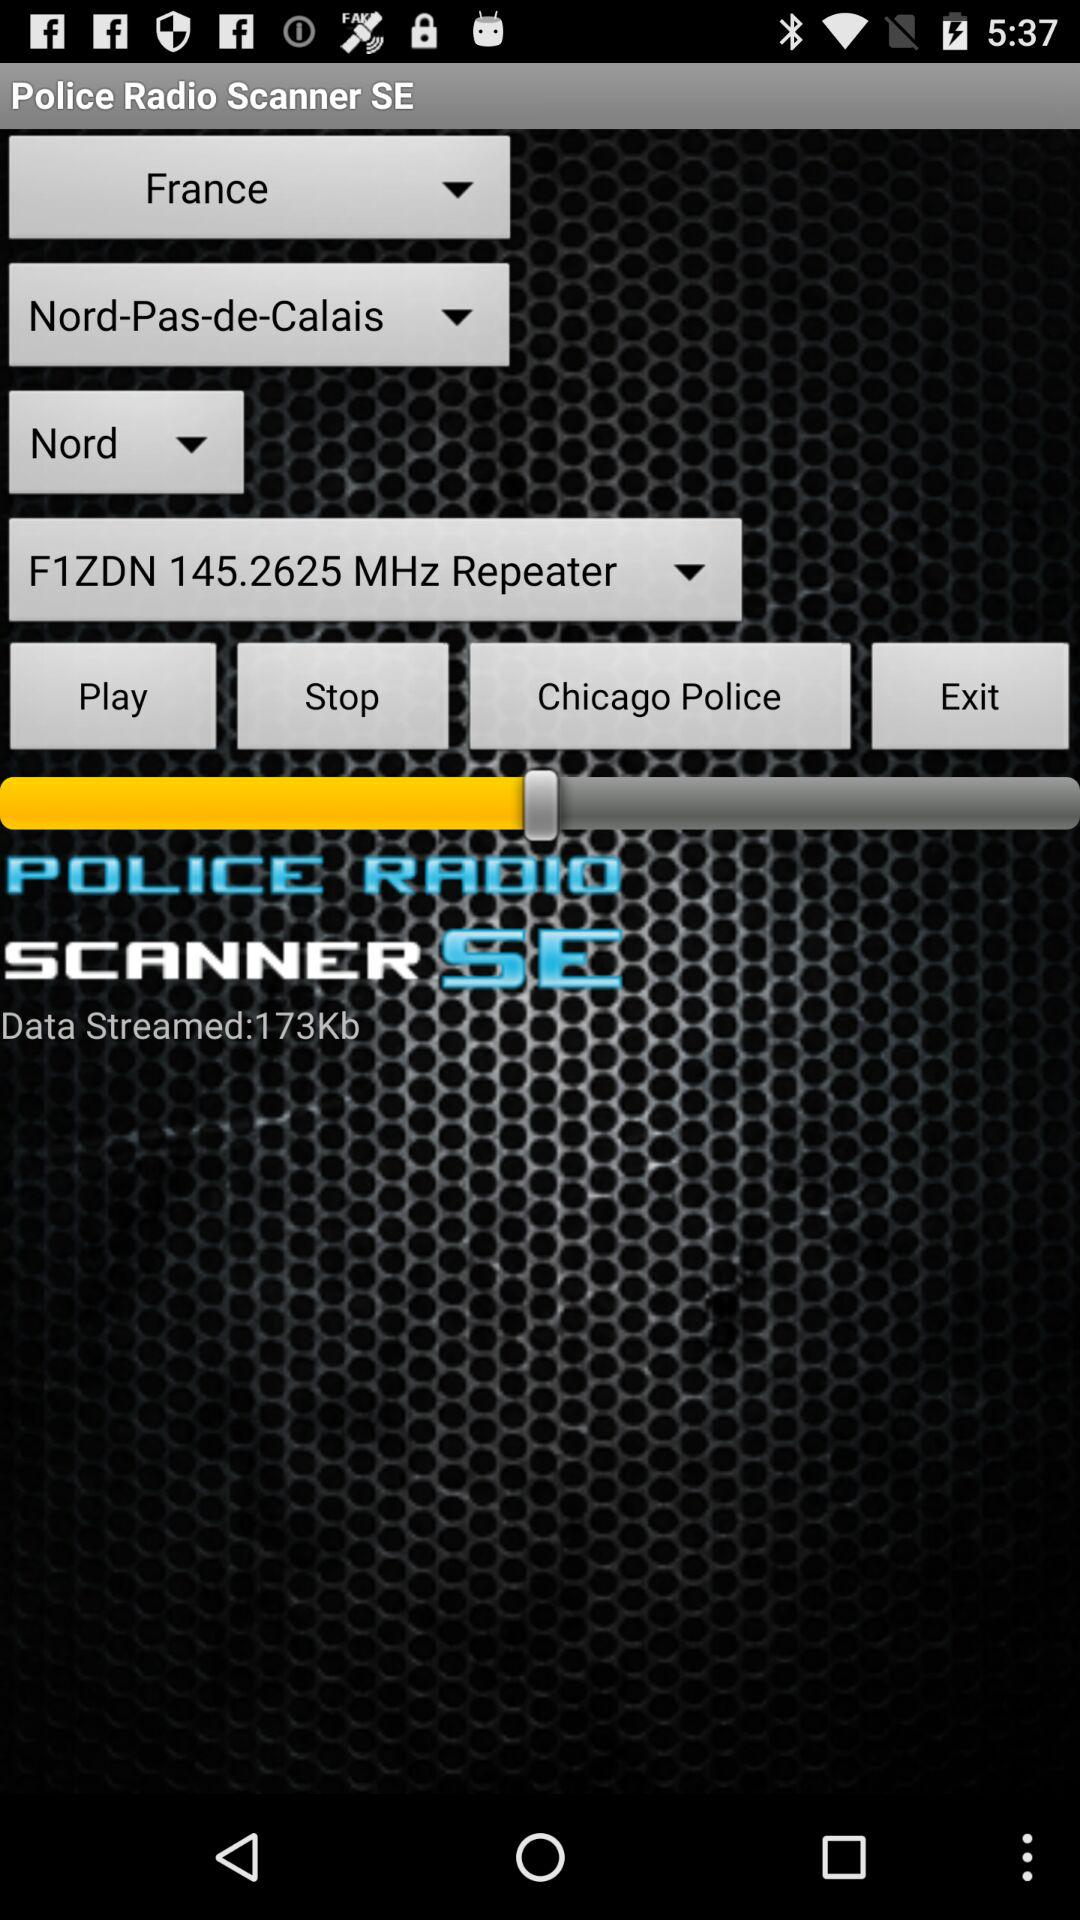How much data has been streamed? The data that has been streamed is 173 Kb. 